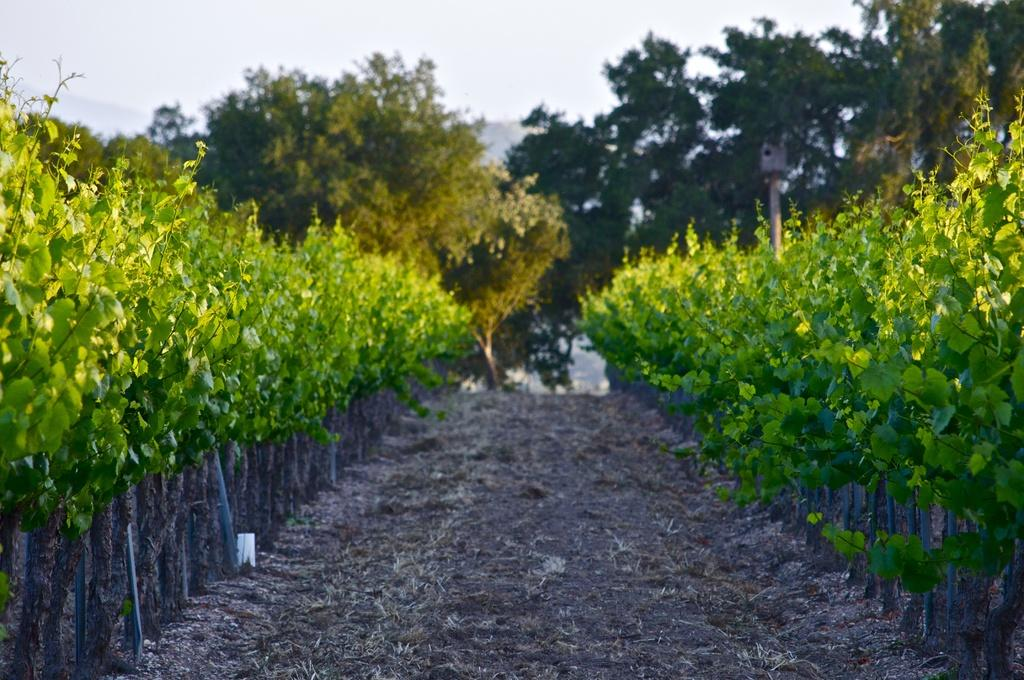What type of path is visible in the image? There is a walkway in the image. What can be seen on the left side of the walkway? There are plants on the left side of the image. What can be seen on the right side of the walkway? There are plants on the right side of the image. What is visible in the background of the image? There are trees and the clear sky visible in the background of the image. What size apple is being used to hammer a nail into the walkway in the image? There is no apple or hammer present in the image; it features a walkway with plants on both sides and trees and a clear sky in the background. 